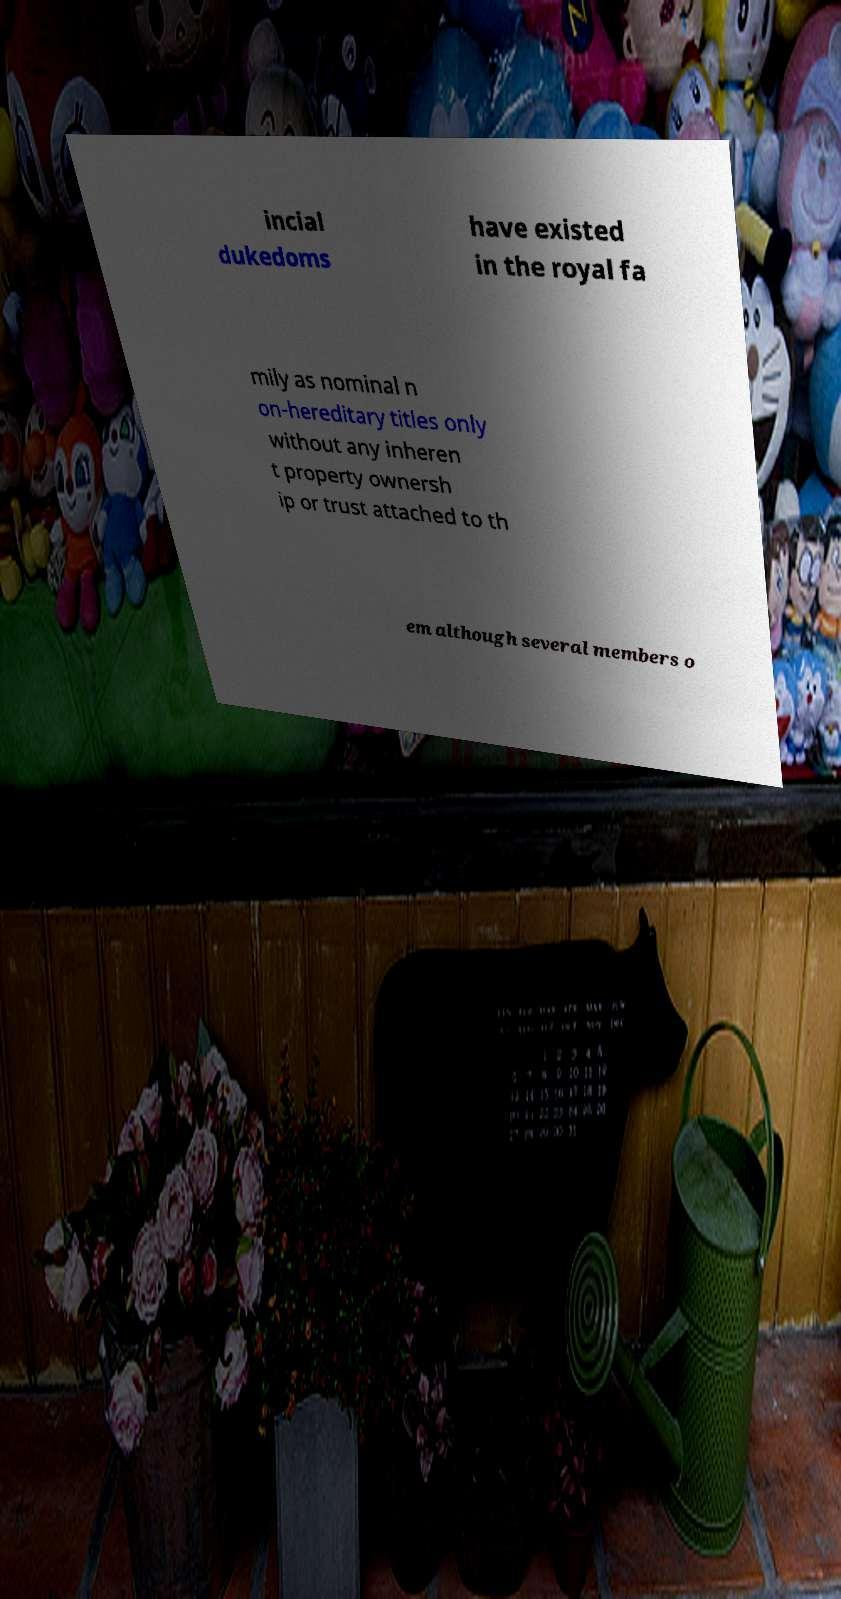Could you extract and type out the text from this image? incial dukedoms have existed in the royal fa mily as nominal n on-hereditary titles only without any inheren t property ownersh ip or trust attached to th em although several members o 